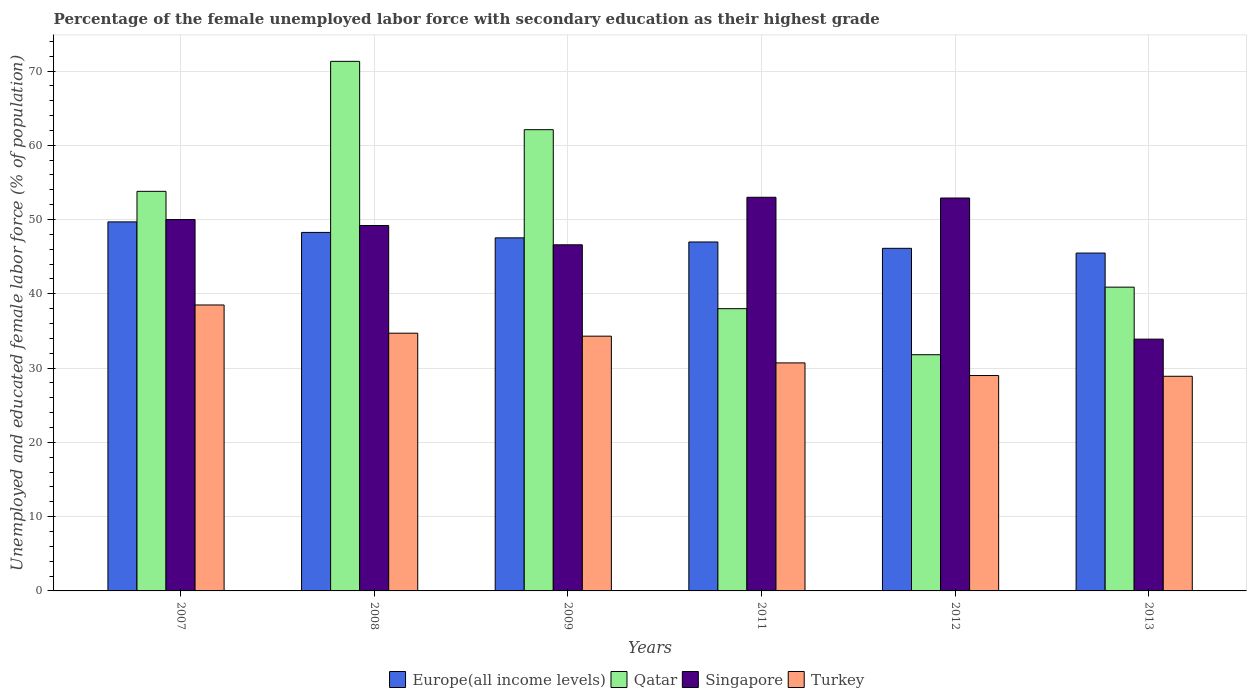How many different coloured bars are there?
Your answer should be very brief. 4. How many bars are there on the 4th tick from the left?
Give a very brief answer. 4. How many bars are there on the 2nd tick from the right?
Offer a terse response. 4. What is the label of the 4th group of bars from the left?
Offer a very short reply. 2011. What is the percentage of the unemployed female labor force with secondary education in Singapore in 2012?
Provide a short and direct response. 52.9. Across all years, what is the minimum percentage of the unemployed female labor force with secondary education in Europe(all income levels)?
Offer a very short reply. 45.49. In which year was the percentage of the unemployed female labor force with secondary education in Singapore maximum?
Offer a very short reply. 2011. What is the total percentage of the unemployed female labor force with secondary education in Qatar in the graph?
Provide a succinct answer. 297.9. What is the difference between the percentage of the unemployed female labor force with secondary education in Turkey in 2008 and that in 2011?
Ensure brevity in your answer.  4. What is the difference between the percentage of the unemployed female labor force with secondary education in Turkey in 2007 and the percentage of the unemployed female labor force with secondary education in Qatar in 2012?
Make the answer very short. 6.7. What is the average percentage of the unemployed female labor force with secondary education in Qatar per year?
Offer a terse response. 49.65. In the year 2011, what is the difference between the percentage of the unemployed female labor force with secondary education in Turkey and percentage of the unemployed female labor force with secondary education in Qatar?
Keep it short and to the point. -7.3. What is the ratio of the percentage of the unemployed female labor force with secondary education in Turkey in 2008 to that in 2012?
Your response must be concise. 1.2. Is the difference between the percentage of the unemployed female labor force with secondary education in Turkey in 2007 and 2012 greater than the difference between the percentage of the unemployed female labor force with secondary education in Qatar in 2007 and 2012?
Provide a succinct answer. No. What is the difference between the highest and the second highest percentage of the unemployed female labor force with secondary education in Singapore?
Keep it short and to the point. 0.1. What is the difference between the highest and the lowest percentage of the unemployed female labor force with secondary education in Turkey?
Provide a short and direct response. 9.6. Is the sum of the percentage of the unemployed female labor force with secondary education in Qatar in 2007 and 2013 greater than the maximum percentage of the unemployed female labor force with secondary education in Singapore across all years?
Provide a succinct answer. Yes. What does the 1st bar from the left in 2009 represents?
Ensure brevity in your answer.  Europe(all income levels). What does the 3rd bar from the right in 2009 represents?
Provide a short and direct response. Qatar. Is it the case that in every year, the sum of the percentage of the unemployed female labor force with secondary education in Europe(all income levels) and percentage of the unemployed female labor force with secondary education in Turkey is greater than the percentage of the unemployed female labor force with secondary education in Singapore?
Provide a short and direct response. Yes. How many bars are there?
Your answer should be compact. 24. Are all the bars in the graph horizontal?
Offer a very short reply. No. How many years are there in the graph?
Keep it short and to the point. 6. Does the graph contain any zero values?
Offer a very short reply. No. Does the graph contain grids?
Give a very brief answer. Yes. What is the title of the graph?
Offer a very short reply. Percentage of the female unemployed labor force with secondary education as their highest grade. What is the label or title of the Y-axis?
Keep it short and to the point. Unemployed and educated female labor force (% of population). What is the Unemployed and educated female labor force (% of population) in Europe(all income levels) in 2007?
Your answer should be very brief. 49.69. What is the Unemployed and educated female labor force (% of population) of Qatar in 2007?
Offer a terse response. 53.8. What is the Unemployed and educated female labor force (% of population) of Turkey in 2007?
Your answer should be very brief. 38.5. What is the Unemployed and educated female labor force (% of population) of Europe(all income levels) in 2008?
Provide a short and direct response. 48.27. What is the Unemployed and educated female labor force (% of population) of Qatar in 2008?
Provide a succinct answer. 71.3. What is the Unemployed and educated female labor force (% of population) of Singapore in 2008?
Make the answer very short. 49.2. What is the Unemployed and educated female labor force (% of population) in Turkey in 2008?
Provide a short and direct response. 34.7. What is the Unemployed and educated female labor force (% of population) in Europe(all income levels) in 2009?
Provide a succinct answer. 47.54. What is the Unemployed and educated female labor force (% of population) in Qatar in 2009?
Your answer should be compact. 62.1. What is the Unemployed and educated female labor force (% of population) in Singapore in 2009?
Make the answer very short. 46.6. What is the Unemployed and educated female labor force (% of population) of Turkey in 2009?
Provide a short and direct response. 34.3. What is the Unemployed and educated female labor force (% of population) of Europe(all income levels) in 2011?
Your response must be concise. 46.98. What is the Unemployed and educated female labor force (% of population) in Qatar in 2011?
Give a very brief answer. 38. What is the Unemployed and educated female labor force (% of population) in Turkey in 2011?
Your response must be concise. 30.7. What is the Unemployed and educated female labor force (% of population) of Europe(all income levels) in 2012?
Make the answer very short. 46.13. What is the Unemployed and educated female labor force (% of population) in Qatar in 2012?
Make the answer very short. 31.8. What is the Unemployed and educated female labor force (% of population) in Singapore in 2012?
Keep it short and to the point. 52.9. What is the Unemployed and educated female labor force (% of population) in Europe(all income levels) in 2013?
Give a very brief answer. 45.49. What is the Unemployed and educated female labor force (% of population) of Qatar in 2013?
Make the answer very short. 40.9. What is the Unemployed and educated female labor force (% of population) of Singapore in 2013?
Make the answer very short. 33.9. What is the Unemployed and educated female labor force (% of population) in Turkey in 2013?
Your response must be concise. 28.9. Across all years, what is the maximum Unemployed and educated female labor force (% of population) of Europe(all income levels)?
Your response must be concise. 49.69. Across all years, what is the maximum Unemployed and educated female labor force (% of population) in Qatar?
Make the answer very short. 71.3. Across all years, what is the maximum Unemployed and educated female labor force (% of population) of Singapore?
Offer a very short reply. 53. Across all years, what is the maximum Unemployed and educated female labor force (% of population) in Turkey?
Provide a succinct answer. 38.5. Across all years, what is the minimum Unemployed and educated female labor force (% of population) in Europe(all income levels)?
Give a very brief answer. 45.49. Across all years, what is the minimum Unemployed and educated female labor force (% of population) of Qatar?
Provide a succinct answer. 31.8. Across all years, what is the minimum Unemployed and educated female labor force (% of population) in Singapore?
Keep it short and to the point. 33.9. Across all years, what is the minimum Unemployed and educated female labor force (% of population) of Turkey?
Offer a very short reply. 28.9. What is the total Unemployed and educated female labor force (% of population) of Europe(all income levels) in the graph?
Offer a terse response. 284.09. What is the total Unemployed and educated female labor force (% of population) of Qatar in the graph?
Offer a terse response. 297.9. What is the total Unemployed and educated female labor force (% of population) of Singapore in the graph?
Give a very brief answer. 285.6. What is the total Unemployed and educated female labor force (% of population) in Turkey in the graph?
Your response must be concise. 196.1. What is the difference between the Unemployed and educated female labor force (% of population) in Europe(all income levels) in 2007 and that in 2008?
Ensure brevity in your answer.  1.42. What is the difference between the Unemployed and educated female labor force (% of population) of Qatar in 2007 and that in 2008?
Your response must be concise. -17.5. What is the difference between the Unemployed and educated female labor force (% of population) of Singapore in 2007 and that in 2008?
Give a very brief answer. 0.8. What is the difference between the Unemployed and educated female labor force (% of population) of Europe(all income levels) in 2007 and that in 2009?
Offer a terse response. 2.15. What is the difference between the Unemployed and educated female labor force (% of population) in Europe(all income levels) in 2007 and that in 2011?
Provide a succinct answer. 2.71. What is the difference between the Unemployed and educated female labor force (% of population) of Singapore in 2007 and that in 2011?
Keep it short and to the point. -3. What is the difference between the Unemployed and educated female labor force (% of population) in Turkey in 2007 and that in 2011?
Provide a short and direct response. 7.8. What is the difference between the Unemployed and educated female labor force (% of population) of Europe(all income levels) in 2007 and that in 2012?
Your response must be concise. 3.56. What is the difference between the Unemployed and educated female labor force (% of population) in Qatar in 2007 and that in 2012?
Provide a succinct answer. 22. What is the difference between the Unemployed and educated female labor force (% of population) in Singapore in 2007 and that in 2012?
Your answer should be very brief. -2.9. What is the difference between the Unemployed and educated female labor force (% of population) in Europe(all income levels) in 2007 and that in 2013?
Offer a very short reply. 4.2. What is the difference between the Unemployed and educated female labor force (% of population) of Turkey in 2007 and that in 2013?
Offer a terse response. 9.6. What is the difference between the Unemployed and educated female labor force (% of population) in Europe(all income levels) in 2008 and that in 2009?
Your answer should be very brief. 0.73. What is the difference between the Unemployed and educated female labor force (% of population) in Qatar in 2008 and that in 2009?
Give a very brief answer. 9.2. What is the difference between the Unemployed and educated female labor force (% of population) in Singapore in 2008 and that in 2009?
Give a very brief answer. 2.6. What is the difference between the Unemployed and educated female labor force (% of population) of Turkey in 2008 and that in 2009?
Your answer should be very brief. 0.4. What is the difference between the Unemployed and educated female labor force (% of population) in Europe(all income levels) in 2008 and that in 2011?
Ensure brevity in your answer.  1.29. What is the difference between the Unemployed and educated female labor force (% of population) of Qatar in 2008 and that in 2011?
Ensure brevity in your answer.  33.3. What is the difference between the Unemployed and educated female labor force (% of population) of Europe(all income levels) in 2008 and that in 2012?
Provide a succinct answer. 2.14. What is the difference between the Unemployed and educated female labor force (% of population) of Qatar in 2008 and that in 2012?
Provide a short and direct response. 39.5. What is the difference between the Unemployed and educated female labor force (% of population) of Singapore in 2008 and that in 2012?
Provide a short and direct response. -3.7. What is the difference between the Unemployed and educated female labor force (% of population) in Europe(all income levels) in 2008 and that in 2013?
Provide a short and direct response. 2.78. What is the difference between the Unemployed and educated female labor force (% of population) in Qatar in 2008 and that in 2013?
Keep it short and to the point. 30.4. What is the difference between the Unemployed and educated female labor force (% of population) of Europe(all income levels) in 2009 and that in 2011?
Your answer should be compact. 0.56. What is the difference between the Unemployed and educated female labor force (% of population) of Qatar in 2009 and that in 2011?
Your answer should be compact. 24.1. What is the difference between the Unemployed and educated female labor force (% of population) in Singapore in 2009 and that in 2011?
Your answer should be compact. -6.4. What is the difference between the Unemployed and educated female labor force (% of population) of Europe(all income levels) in 2009 and that in 2012?
Provide a short and direct response. 1.41. What is the difference between the Unemployed and educated female labor force (% of population) in Qatar in 2009 and that in 2012?
Your answer should be compact. 30.3. What is the difference between the Unemployed and educated female labor force (% of population) of Europe(all income levels) in 2009 and that in 2013?
Provide a short and direct response. 2.05. What is the difference between the Unemployed and educated female labor force (% of population) in Qatar in 2009 and that in 2013?
Offer a very short reply. 21.2. What is the difference between the Unemployed and educated female labor force (% of population) in Singapore in 2009 and that in 2013?
Provide a short and direct response. 12.7. What is the difference between the Unemployed and educated female labor force (% of population) of Europe(all income levels) in 2011 and that in 2012?
Offer a terse response. 0.85. What is the difference between the Unemployed and educated female labor force (% of population) in Qatar in 2011 and that in 2012?
Give a very brief answer. 6.2. What is the difference between the Unemployed and educated female labor force (% of population) of Singapore in 2011 and that in 2012?
Provide a succinct answer. 0.1. What is the difference between the Unemployed and educated female labor force (% of population) of Europe(all income levels) in 2011 and that in 2013?
Ensure brevity in your answer.  1.49. What is the difference between the Unemployed and educated female labor force (% of population) in Turkey in 2011 and that in 2013?
Give a very brief answer. 1.8. What is the difference between the Unemployed and educated female labor force (% of population) of Europe(all income levels) in 2012 and that in 2013?
Give a very brief answer. 0.64. What is the difference between the Unemployed and educated female labor force (% of population) of Qatar in 2012 and that in 2013?
Keep it short and to the point. -9.1. What is the difference between the Unemployed and educated female labor force (% of population) of Singapore in 2012 and that in 2013?
Offer a very short reply. 19. What is the difference between the Unemployed and educated female labor force (% of population) of Europe(all income levels) in 2007 and the Unemployed and educated female labor force (% of population) of Qatar in 2008?
Keep it short and to the point. -21.61. What is the difference between the Unemployed and educated female labor force (% of population) of Europe(all income levels) in 2007 and the Unemployed and educated female labor force (% of population) of Singapore in 2008?
Offer a very short reply. 0.49. What is the difference between the Unemployed and educated female labor force (% of population) in Europe(all income levels) in 2007 and the Unemployed and educated female labor force (% of population) in Turkey in 2008?
Offer a very short reply. 14.99. What is the difference between the Unemployed and educated female labor force (% of population) of Singapore in 2007 and the Unemployed and educated female labor force (% of population) of Turkey in 2008?
Your response must be concise. 15.3. What is the difference between the Unemployed and educated female labor force (% of population) of Europe(all income levels) in 2007 and the Unemployed and educated female labor force (% of population) of Qatar in 2009?
Your response must be concise. -12.41. What is the difference between the Unemployed and educated female labor force (% of population) in Europe(all income levels) in 2007 and the Unemployed and educated female labor force (% of population) in Singapore in 2009?
Your answer should be compact. 3.09. What is the difference between the Unemployed and educated female labor force (% of population) in Europe(all income levels) in 2007 and the Unemployed and educated female labor force (% of population) in Turkey in 2009?
Give a very brief answer. 15.39. What is the difference between the Unemployed and educated female labor force (% of population) of Qatar in 2007 and the Unemployed and educated female labor force (% of population) of Singapore in 2009?
Provide a short and direct response. 7.2. What is the difference between the Unemployed and educated female labor force (% of population) of Singapore in 2007 and the Unemployed and educated female labor force (% of population) of Turkey in 2009?
Ensure brevity in your answer.  15.7. What is the difference between the Unemployed and educated female labor force (% of population) of Europe(all income levels) in 2007 and the Unemployed and educated female labor force (% of population) of Qatar in 2011?
Give a very brief answer. 11.69. What is the difference between the Unemployed and educated female labor force (% of population) in Europe(all income levels) in 2007 and the Unemployed and educated female labor force (% of population) in Singapore in 2011?
Your answer should be very brief. -3.31. What is the difference between the Unemployed and educated female labor force (% of population) of Europe(all income levels) in 2007 and the Unemployed and educated female labor force (% of population) of Turkey in 2011?
Provide a short and direct response. 18.99. What is the difference between the Unemployed and educated female labor force (% of population) in Qatar in 2007 and the Unemployed and educated female labor force (% of population) in Singapore in 2011?
Make the answer very short. 0.8. What is the difference between the Unemployed and educated female labor force (% of population) of Qatar in 2007 and the Unemployed and educated female labor force (% of population) of Turkey in 2011?
Make the answer very short. 23.1. What is the difference between the Unemployed and educated female labor force (% of population) of Singapore in 2007 and the Unemployed and educated female labor force (% of population) of Turkey in 2011?
Provide a succinct answer. 19.3. What is the difference between the Unemployed and educated female labor force (% of population) of Europe(all income levels) in 2007 and the Unemployed and educated female labor force (% of population) of Qatar in 2012?
Your response must be concise. 17.89. What is the difference between the Unemployed and educated female labor force (% of population) in Europe(all income levels) in 2007 and the Unemployed and educated female labor force (% of population) in Singapore in 2012?
Provide a succinct answer. -3.21. What is the difference between the Unemployed and educated female labor force (% of population) in Europe(all income levels) in 2007 and the Unemployed and educated female labor force (% of population) in Turkey in 2012?
Your answer should be compact. 20.69. What is the difference between the Unemployed and educated female labor force (% of population) of Qatar in 2007 and the Unemployed and educated female labor force (% of population) of Turkey in 2012?
Make the answer very short. 24.8. What is the difference between the Unemployed and educated female labor force (% of population) of Singapore in 2007 and the Unemployed and educated female labor force (% of population) of Turkey in 2012?
Offer a terse response. 21. What is the difference between the Unemployed and educated female labor force (% of population) of Europe(all income levels) in 2007 and the Unemployed and educated female labor force (% of population) of Qatar in 2013?
Keep it short and to the point. 8.79. What is the difference between the Unemployed and educated female labor force (% of population) in Europe(all income levels) in 2007 and the Unemployed and educated female labor force (% of population) in Singapore in 2013?
Give a very brief answer. 15.79. What is the difference between the Unemployed and educated female labor force (% of population) in Europe(all income levels) in 2007 and the Unemployed and educated female labor force (% of population) in Turkey in 2013?
Your response must be concise. 20.79. What is the difference between the Unemployed and educated female labor force (% of population) in Qatar in 2007 and the Unemployed and educated female labor force (% of population) in Singapore in 2013?
Your answer should be compact. 19.9. What is the difference between the Unemployed and educated female labor force (% of population) of Qatar in 2007 and the Unemployed and educated female labor force (% of population) of Turkey in 2013?
Offer a very short reply. 24.9. What is the difference between the Unemployed and educated female labor force (% of population) of Singapore in 2007 and the Unemployed and educated female labor force (% of population) of Turkey in 2013?
Provide a succinct answer. 21.1. What is the difference between the Unemployed and educated female labor force (% of population) of Europe(all income levels) in 2008 and the Unemployed and educated female labor force (% of population) of Qatar in 2009?
Offer a terse response. -13.83. What is the difference between the Unemployed and educated female labor force (% of population) of Europe(all income levels) in 2008 and the Unemployed and educated female labor force (% of population) of Singapore in 2009?
Offer a very short reply. 1.67. What is the difference between the Unemployed and educated female labor force (% of population) of Europe(all income levels) in 2008 and the Unemployed and educated female labor force (% of population) of Turkey in 2009?
Provide a succinct answer. 13.97. What is the difference between the Unemployed and educated female labor force (% of population) in Qatar in 2008 and the Unemployed and educated female labor force (% of population) in Singapore in 2009?
Provide a short and direct response. 24.7. What is the difference between the Unemployed and educated female labor force (% of population) in Europe(all income levels) in 2008 and the Unemployed and educated female labor force (% of population) in Qatar in 2011?
Your answer should be compact. 10.27. What is the difference between the Unemployed and educated female labor force (% of population) in Europe(all income levels) in 2008 and the Unemployed and educated female labor force (% of population) in Singapore in 2011?
Offer a very short reply. -4.73. What is the difference between the Unemployed and educated female labor force (% of population) of Europe(all income levels) in 2008 and the Unemployed and educated female labor force (% of population) of Turkey in 2011?
Keep it short and to the point. 17.57. What is the difference between the Unemployed and educated female labor force (% of population) in Qatar in 2008 and the Unemployed and educated female labor force (% of population) in Turkey in 2011?
Give a very brief answer. 40.6. What is the difference between the Unemployed and educated female labor force (% of population) of Europe(all income levels) in 2008 and the Unemployed and educated female labor force (% of population) of Qatar in 2012?
Your answer should be compact. 16.47. What is the difference between the Unemployed and educated female labor force (% of population) in Europe(all income levels) in 2008 and the Unemployed and educated female labor force (% of population) in Singapore in 2012?
Keep it short and to the point. -4.63. What is the difference between the Unemployed and educated female labor force (% of population) of Europe(all income levels) in 2008 and the Unemployed and educated female labor force (% of population) of Turkey in 2012?
Make the answer very short. 19.27. What is the difference between the Unemployed and educated female labor force (% of population) in Qatar in 2008 and the Unemployed and educated female labor force (% of population) in Singapore in 2012?
Your response must be concise. 18.4. What is the difference between the Unemployed and educated female labor force (% of population) in Qatar in 2008 and the Unemployed and educated female labor force (% of population) in Turkey in 2012?
Give a very brief answer. 42.3. What is the difference between the Unemployed and educated female labor force (% of population) in Singapore in 2008 and the Unemployed and educated female labor force (% of population) in Turkey in 2012?
Offer a very short reply. 20.2. What is the difference between the Unemployed and educated female labor force (% of population) in Europe(all income levels) in 2008 and the Unemployed and educated female labor force (% of population) in Qatar in 2013?
Keep it short and to the point. 7.37. What is the difference between the Unemployed and educated female labor force (% of population) of Europe(all income levels) in 2008 and the Unemployed and educated female labor force (% of population) of Singapore in 2013?
Keep it short and to the point. 14.37. What is the difference between the Unemployed and educated female labor force (% of population) in Europe(all income levels) in 2008 and the Unemployed and educated female labor force (% of population) in Turkey in 2013?
Give a very brief answer. 19.37. What is the difference between the Unemployed and educated female labor force (% of population) of Qatar in 2008 and the Unemployed and educated female labor force (% of population) of Singapore in 2013?
Your answer should be compact. 37.4. What is the difference between the Unemployed and educated female labor force (% of population) of Qatar in 2008 and the Unemployed and educated female labor force (% of population) of Turkey in 2013?
Ensure brevity in your answer.  42.4. What is the difference between the Unemployed and educated female labor force (% of population) of Singapore in 2008 and the Unemployed and educated female labor force (% of population) of Turkey in 2013?
Make the answer very short. 20.3. What is the difference between the Unemployed and educated female labor force (% of population) in Europe(all income levels) in 2009 and the Unemployed and educated female labor force (% of population) in Qatar in 2011?
Your response must be concise. 9.54. What is the difference between the Unemployed and educated female labor force (% of population) of Europe(all income levels) in 2009 and the Unemployed and educated female labor force (% of population) of Singapore in 2011?
Your answer should be very brief. -5.46. What is the difference between the Unemployed and educated female labor force (% of population) of Europe(all income levels) in 2009 and the Unemployed and educated female labor force (% of population) of Turkey in 2011?
Your response must be concise. 16.84. What is the difference between the Unemployed and educated female labor force (% of population) of Qatar in 2009 and the Unemployed and educated female labor force (% of population) of Singapore in 2011?
Your answer should be very brief. 9.1. What is the difference between the Unemployed and educated female labor force (% of population) of Qatar in 2009 and the Unemployed and educated female labor force (% of population) of Turkey in 2011?
Give a very brief answer. 31.4. What is the difference between the Unemployed and educated female labor force (% of population) in Singapore in 2009 and the Unemployed and educated female labor force (% of population) in Turkey in 2011?
Your answer should be very brief. 15.9. What is the difference between the Unemployed and educated female labor force (% of population) of Europe(all income levels) in 2009 and the Unemployed and educated female labor force (% of population) of Qatar in 2012?
Ensure brevity in your answer.  15.74. What is the difference between the Unemployed and educated female labor force (% of population) in Europe(all income levels) in 2009 and the Unemployed and educated female labor force (% of population) in Singapore in 2012?
Your answer should be very brief. -5.36. What is the difference between the Unemployed and educated female labor force (% of population) of Europe(all income levels) in 2009 and the Unemployed and educated female labor force (% of population) of Turkey in 2012?
Your answer should be very brief. 18.54. What is the difference between the Unemployed and educated female labor force (% of population) in Qatar in 2009 and the Unemployed and educated female labor force (% of population) in Singapore in 2012?
Ensure brevity in your answer.  9.2. What is the difference between the Unemployed and educated female labor force (% of population) of Qatar in 2009 and the Unemployed and educated female labor force (% of population) of Turkey in 2012?
Make the answer very short. 33.1. What is the difference between the Unemployed and educated female labor force (% of population) of Singapore in 2009 and the Unemployed and educated female labor force (% of population) of Turkey in 2012?
Your answer should be compact. 17.6. What is the difference between the Unemployed and educated female labor force (% of population) of Europe(all income levels) in 2009 and the Unemployed and educated female labor force (% of population) of Qatar in 2013?
Give a very brief answer. 6.64. What is the difference between the Unemployed and educated female labor force (% of population) of Europe(all income levels) in 2009 and the Unemployed and educated female labor force (% of population) of Singapore in 2013?
Your answer should be very brief. 13.64. What is the difference between the Unemployed and educated female labor force (% of population) of Europe(all income levels) in 2009 and the Unemployed and educated female labor force (% of population) of Turkey in 2013?
Ensure brevity in your answer.  18.64. What is the difference between the Unemployed and educated female labor force (% of population) of Qatar in 2009 and the Unemployed and educated female labor force (% of population) of Singapore in 2013?
Your response must be concise. 28.2. What is the difference between the Unemployed and educated female labor force (% of population) in Qatar in 2009 and the Unemployed and educated female labor force (% of population) in Turkey in 2013?
Give a very brief answer. 33.2. What is the difference between the Unemployed and educated female labor force (% of population) in Europe(all income levels) in 2011 and the Unemployed and educated female labor force (% of population) in Qatar in 2012?
Your response must be concise. 15.18. What is the difference between the Unemployed and educated female labor force (% of population) of Europe(all income levels) in 2011 and the Unemployed and educated female labor force (% of population) of Singapore in 2012?
Keep it short and to the point. -5.92. What is the difference between the Unemployed and educated female labor force (% of population) in Europe(all income levels) in 2011 and the Unemployed and educated female labor force (% of population) in Turkey in 2012?
Keep it short and to the point. 17.98. What is the difference between the Unemployed and educated female labor force (% of population) of Qatar in 2011 and the Unemployed and educated female labor force (% of population) of Singapore in 2012?
Your answer should be compact. -14.9. What is the difference between the Unemployed and educated female labor force (% of population) of Qatar in 2011 and the Unemployed and educated female labor force (% of population) of Turkey in 2012?
Your answer should be very brief. 9. What is the difference between the Unemployed and educated female labor force (% of population) in Singapore in 2011 and the Unemployed and educated female labor force (% of population) in Turkey in 2012?
Make the answer very short. 24. What is the difference between the Unemployed and educated female labor force (% of population) of Europe(all income levels) in 2011 and the Unemployed and educated female labor force (% of population) of Qatar in 2013?
Offer a very short reply. 6.08. What is the difference between the Unemployed and educated female labor force (% of population) of Europe(all income levels) in 2011 and the Unemployed and educated female labor force (% of population) of Singapore in 2013?
Offer a very short reply. 13.08. What is the difference between the Unemployed and educated female labor force (% of population) in Europe(all income levels) in 2011 and the Unemployed and educated female labor force (% of population) in Turkey in 2013?
Your answer should be compact. 18.08. What is the difference between the Unemployed and educated female labor force (% of population) in Qatar in 2011 and the Unemployed and educated female labor force (% of population) in Turkey in 2013?
Your response must be concise. 9.1. What is the difference between the Unemployed and educated female labor force (% of population) in Singapore in 2011 and the Unemployed and educated female labor force (% of population) in Turkey in 2013?
Give a very brief answer. 24.1. What is the difference between the Unemployed and educated female labor force (% of population) in Europe(all income levels) in 2012 and the Unemployed and educated female labor force (% of population) in Qatar in 2013?
Your answer should be compact. 5.23. What is the difference between the Unemployed and educated female labor force (% of population) in Europe(all income levels) in 2012 and the Unemployed and educated female labor force (% of population) in Singapore in 2013?
Make the answer very short. 12.23. What is the difference between the Unemployed and educated female labor force (% of population) in Europe(all income levels) in 2012 and the Unemployed and educated female labor force (% of population) in Turkey in 2013?
Your answer should be very brief. 17.23. What is the average Unemployed and educated female labor force (% of population) in Europe(all income levels) per year?
Provide a short and direct response. 47.35. What is the average Unemployed and educated female labor force (% of population) in Qatar per year?
Offer a very short reply. 49.65. What is the average Unemployed and educated female labor force (% of population) of Singapore per year?
Offer a terse response. 47.6. What is the average Unemployed and educated female labor force (% of population) of Turkey per year?
Keep it short and to the point. 32.68. In the year 2007, what is the difference between the Unemployed and educated female labor force (% of population) of Europe(all income levels) and Unemployed and educated female labor force (% of population) of Qatar?
Your answer should be compact. -4.11. In the year 2007, what is the difference between the Unemployed and educated female labor force (% of population) in Europe(all income levels) and Unemployed and educated female labor force (% of population) in Singapore?
Make the answer very short. -0.31. In the year 2007, what is the difference between the Unemployed and educated female labor force (% of population) in Europe(all income levels) and Unemployed and educated female labor force (% of population) in Turkey?
Provide a succinct answer. 11.19. In the year 2007, what is the difference between the Unemployed and educated female labor force (% of population) in Qatar and Unemployed and educated female labor force (% of population) in Turkey?
Provide a short and direct response. 15.3. In the year 2007, what is the difference between the Unemployed and educated female labor force (% of population) of Singapore and Unemployed and educated female labor force (% of population) of Turkey?
Your answer should be compact. 11.5. In the year 2008, what is the difference between the Unemployed and educated female labor force (% of population) in Europe(all income levels) and Unemployed and educated female labor force (% of population) in Qatar?
Your answer should be very brief. -23.03. In the year 2008, what is the difference between the Unemployed and educated female labor force (% of population) of Europe(all income levels) and Unemployed and educated female labor force (% of population) of Singapore?
Offer a terse response. -0.93. In the year 2008, what is the difference between the Unemployed and educated female labor force (% of population) of Europe(all income levels) and Unemployed and educated female labor force (% of population) of Turkey?
Make the answer very short. 13.57. In the year 2008, what is the difference between the Unemployed and educated female labor force (% of population) in Qatar and Unemployed and educated female labor force (% of population) in Singapore?
Provide a short and direct response. 22.1. In the year 2008, what is the difference between the Unemployed and educated female labor force (% of population) of Qatar and Unemployed and educated female labor force (% of population) of Turkey?
Give a very brief answer. 36.6. In the year 2009, what is the difference between the Unemployed and educated female labor force (% of population) in Europe(all income levels) and Unemployed and educated female labor force (% of population) in Qatar?
Your answer should be very brief. -14.56. In the year 2009, what is the difference between the Unemployed and educated female labor force (% of population) of Europe(all income levels) and Unemployed and educated female labor force (% of population) of Singapore?
Offer a terse response. 0.94. In the year 2009, what is the difference between the Unemployed and educated female labor force (% of population) in Europe(all income levels) and Unemployed and educated female labor force (% of population) in Turkey?
Keep it short and to the point. 13.24. In the year 2009, what is the difference between the Unemployed and educated female labor force (% of population) of Qatar and Unemployed and educated female labor force (% of population) of Singapore?
Provide a succinct answer. 15.5. In the year 2009, what is the difference between the Unemployed and educated female labor force (% of population) in Qatar and Unemployed and educated female labor force (% of population) in Turkey?
Your response must be concise. 27.8. In the year 2009, what is the difference between the Unemployed and educated female labor force (% of population) of Singapore and Unemployed and educated female labor force (% of population) of Turkey?
Provide a succinct answer. 12.3. In the year 2011, what is the difference between the Unemployed and educated female labor force (% of population) in Europe(all income levels) and Unemployed and educated female labor force (% of population) in Qatar?
Your answer should be compact. 8.98. In the year 2011, what is the difference between the Unemployed and educated female labor force (% of population) in Europe(all income levels) and Unemployed and educated female labor force (% of population) in Singapore?
Provide a succinct answer. -6.02. In the year 2011, what is the difference between the Unemployed and educated female labor force (% of population) of Europe(all income levels) and Unemployed and educated female labor force (% of population) of Turkey?
Keep it short and to the point. 16.28. In the year 2011, what is the difference between the Unemployed and educated female labor force (% of population) of Qatar and Unemployed and educated female labor force (% of population) of Turkey?
Offer a terse response. 7.3. In the year 2011, what is the difference between the Unemployed and educated female labor force (% of population) in Singapore and Unemployed and educated female labor force (% of population) in Turkey?
Provide a short and direct response. 22.3. In the year 2012, what is the difference between the Unemployed and educated female labor force (% of population) in Europe(all income levels) and Unemployed and educated female labor force (% of population) in Qatar?
Give a very brief answer. 14.33. In the year 2012, what is the difference between the Unemployed and educated female labor force (% of population) in Europe(all income levels) and Unemployed and educated female labor force (% of population) in Singapore?
Your response must be concise. -6.77. In the year 2012, what is the difference between the Unemployed and educated female labor force (% of population) in Europe(all income levels) and Unemployed and educated female labor force (% of population) in Turkey?
Your answer should be compact. 17.13. In the year 2012, what is the difference between the Unemployed and educated female labor force (% of population) in Qatar and Unemployed and educated female labor force (% of population) in Singapore?
Make the answer very short. -21.1. In the year 2012, what is the difference between the Unemployed and educated female labor force (% of population) in Qatar and Unemployed and educated female labor force (% of population) in Turkey?
Give a very brief answer. 2.8. In the year 2012, what is the difference between the Unemployed and educated female labor force (% of population) of Singapore and Unemployed and educated female labor force (% of population) of Turkey?
Make the answer very short. 23.9. In the year 2013, what is the difference between the Unemployed and educated female labor force (% of population) in Europe(all income levels) and Unemployed and educated female labor force (% of population) in Qatar?
Give a very brief answer. 4.59. In the year 2013, what is the difference between the Unemployed and educated female labor force (% of population) of Europe(all income levels) and Unemployed and educated female labor force (% of population) of Singapore?
Offer a terse response. 11.59. In the year 2013, what is the difference between the Unemployed and educated female labor force (% of population) of Europe(all income levels) and Unemployed and educated female labor force (% of population) of Turkey?
Offer a very short reply. 16.59. In the year 2013, what is the difference between the Unemployed and educated female labor force (% of population) of Qatar and Unemployed and educated female labor force (% of population) of Singapore?
Provide a succinct answer. 7. In the year 2013, what is the difference between the Unemployed and educated female labor force (% of population) of Qatar and Unemployed and educated female labor force (% of population) of Turkey?
Make the answer very short. 12. In the year 2013, what is the difference between the Unemployed and educated female labor force (% of population) of Singapore and Unemployed and educated female labor force (% of population) of Turkey?
Give a very brief answer. 5. What is the ratio of the Unemployed and educated female labor force (% of population) of Europe(all income levels) in 2007 to that in 2008?
Provide a succinct answer. 1.03. What is the ratio of the Unemployed and educated female labor force (% of population) in Qatar in 2007 to that in 2008?
Provide a short and direct response. 0.75. What is the ratio of the Unemployed and educated female labor force (% of population) in Singapore in 2007 to that in 2008?
Keep it short and to the point. 1.02. What is the ratio of the Unemployed and educated female labor force (% of population) in Turkey in 2007 to that in 2008?
Keep it short and to the point. 1.11. What is the ratio of the Unemployed and educated female labor force (% of population) in Europe(all income levels) in 2007 to that in 2009?
Your answer should be very brief. 1.05. What is the ratio of the Unemployed and educated female labor force (% of population) in Qatar in 2007 to that in 2009?
Your response must be concise. 0.87. What is the ratio of the Unemployed and educated female labor force (% of population) in Singapore in 2007 to that in 2009?
Your answer should be very brief. 1.07. What is the ratio of the Unemployed and educated female labor force (% of population) of Turkey in 2007 to that in 2009?
Give a very brief answer. 1.12. What is the ratio of the Unemployed and educated female labor force (% of population) of Europe(all income levels) in 2007 to that in 2011?
Ensure brevity in your answer.  1.06. What is the ratio of the Unemployed and educated female labor force (% of population) of Qatar in 2007 to that in 2011?
Offer a very short reply. 1.42. What is the ratio of the Unemployed and educated female labor force (% of population) in Singapore in 2007 to that in 2011?
Your answer should be very brief. 0.94. What is the ratio of the Unemployed and educated female labor force (% of population) of Turkey in 2007 to that in 2011?
Your response must be concise. 1.25. What is the ratio of the Unemployed and educated female labor force (% of population) of Europe(all income levels) in 2007 to that in 2012?
Keep it short and to the point. 1.08. What is the ratio of the Unemployed and educated female labor force (% of population) of Qatar in 2007 to that in 2012?
Provide a short and direct response. 1.69. What is the ratio of the Unemployed and educated female labor force (% of population) of Singapore in 2007 to that in 2012?
Your answer should be compact. 0.95. What is the ratio of the Unemployed and educated female labor force (% of population) of Turkey in 2007 to that in 2012?
Keep it short and to the point. 1.33. What is the ratio of the Unemployed and educated female labor force (% of population) in Europe(all income levels) in 2007 to that in 2013?
Make the answer very short. 1.09. What is the ratio of the Unemployed and educated female labor force (% of population) of Qatar in 2007 to that in 2013?
Your answer should be very brief. 1.32. What is the ratio of the Unemployed and educated female labor force (% of population) of Singapore in 2007 to that in 2013?
Offer a very short reply. 1.47. What is the ratio of the Unemployed and educated female labor force (% of population) of Turkey in 2007 to that in 2013?
Give a very brief answer. 1.33. What is the ratio of the Unemployed and educated female labor force (% of population) of Europe(all income levels) in 2008 to that in 2009?
Your answer should be compact. 1.02. What is the ratio of the Unemployed and educated female labor force (% of population) of Qatar in 2008 to that in 2009?
Make the answer very short. 1.15. What is the ratio of the Unemployed and educated female labor force (% of population) of Singapore in 2008 to that in 2009?
Give a very brief answer. 1.06. What is the ratio of the Unemployed and educated female labor force (% of population) in Turkey in 2008 to that in 2009?
Provide a succinct answer. 1.01. What is the ratio of the Unemployed and educated female labor force (% of population) of Europe(all income levels) in 2008 to that in 2011?
Make the answer very short. 1.03. What is the ratio of the Unemployed and educated female labor force (% of population) in Qatar in 2008 to that in 2011?
Make the answer very short. 1.88. What is the ratio of the Unemployed and educated female labor force (% of population) in Singapore in 2008 to that in 2011?
Give a very brief answer. 0.93. What is the ratio of the Unemployed and educated female labor force (% of population) in Turkey in 2008 to that in 2011?
Provide a short and direct response. 1.13. What is the ratio of the Unemployed and educated female labor force (% of population) in Europe(all income levels) in 2008 to that in 2012?
Offer a terse response. 1.05. What is the ratio of the Unemployed and educated female labor force (% of population) of Qatar in 2008 to that in 2012?
Your answer should be compact. 2.24. What is the ratio of the Unemployed and educated female labor force (% of population) in Singapore in 2008 to that in 2012?
Ensure brevity in your answer.  0.93. What is the ratio of the Unemployed and educated female labor force (% of population) in Turkey in 2008 to that in 2012?
Your answer should be compact. 1.2. What is the ratio of the Unemployed and educated female labor force (% of population) in Europe(all income levels) in 2008 to that in 2013?
Your response must be concise. 1.06. What is the ratio of the Unemployed and educated female labor force (% of population) in Qatar in 2008 to that in 2013?
Keep it short and to the point. 1.74. What is the ratio of the Unemployed and educated female labor force (% of population) in Singapore in 2008 to that in 2013?
Your answer should be very brief. 1.45. What is the ratio of the Unemployed and educated female labor force (% of population) of Turkey in 2008 to that in 2013?
Give a very brief answer. 1.2. What is the ratio of the Unemployed and educated female labor force (% of population) of Europe(all income levels) in 2009 to that in 2011?
Provide a succinct answer. 1.01. What is the ratio of the Unemployed and educated female labor force (% of population) in Qatar in 2009 to that in 2011?
Your answer should be compact. 1.63. What is the ratio of the Unemployed and educated female labor force (% of population) of Singapore in 2009 to that in 2011?
Provide a short and direct response. 0.88. What is the ratio of the Unemployed and educated female labor force (% of population) in Turkey in 2009 to that in 2011?
Make the answer very short. 1.12. What is the ratio of the Unemployed and educated female labor force (% of population) of Europe(all income levels) in 2009 to that in 2012?
Make the answer very short. 1.03. What is the ratio of the Unemployed and educated female labor force (% of population) of Qatar in 2009 to that in 2012?
Give a very brief answer. 1.95. What is the ratio of the Unemployed and educated female labor force (% of population) in Singapore in 2009 to that in 2012?
Offer a terse response. 0.88. What is the ratio of the Unemployed and educated female labor force (% of population) in Turkey in 2009 to that in 2012?
Keep it short and to the point. 1.18. What is the ratio of the Unemployed and educated female labor force (% of population) in Europe(all income levels) in 2009 to that in 2013?
Make the answer very short. 1.04. What is the ratio of the Unemployed and educated female labor force (% of population) of Qatar in 2009 to that in 2013?
Give a very brief answer. 1.52. What is the ratio of the Unemployed and educated female labor force (% of population) of Singapore in 2009 to that in 2013?
Your answer should be compact. 1.37. What is the ratio of the Unemployed and educated female labor force (% of population) of Turkey in 2009 to that in 2013?
Offer a very short reply. 1.19. What is the ratio of the Unemployed and educated female labor force (% of population) of Europe(all income levels) in 2011 to that in 2012?
Keep it short and to the point. 1.02. What is the ratio of the Unemployed and educated female labor force (% of population) of Qatar in 2011 to that in 2012?
Offer a terse response. 1.2. What is the ratio of the Unemployed and educated female labor force (% of population) of Singapore in 2011 to that in 2012?
Your answer should be very brief. 1. What is the ratio of the Unemployed and educated female labor force (% of population) of Turkey in 2011 to that in 2012?
Ensure brevity in your answer.  1.06. What is the ratio of the Unemployed and educated female labor force (% of population) in Europe(all income levels) in 2011 to that in 2013?
Your answer should be very brief. 1.03. What is the ratio of the Unemployed and educated female labor force (% of population) of Qatar in 2011 to that in 2013?
Make the answer very short. 0.93. What is the ratio of the Unemployed and educated female labor force (% of population) in Singapore in 2011 to that in 2013?
Offer a terse response. 1.56. What is the ratio of the Unemployed and educated female labor force (% of population) of Turkey in 2011 to that in 2013?
Ensure brevity in your answer.  1.06. What is the ratio of the Unemployed and educated female labor force (% of population) in Europe(all income levels) in 2012 to that in 2013?
Offer a very short reply. 1.01. What is the ratio of the Unemployed and educated female labor force (% of population) of Qatar in 2012 to that in 2013?
Give a very brief answer. 0.78. What is the ratio of the Unemployed and educated female labor force (% of population) in Singapore in 2012 to that in 2013?
Offer a terse response. 1.56. What is the ratio of the Unemployed and educated female labor force (% of population) in Turkey in 2012 to that in 2013?
Provide a succinct answer. 1. What is the difference between the highest and the second highest Unemployed and educated female labor force (% of population) in Europe(all income levels)?
Keep it short and to the point. 1.42. What is the difference between the highest and the second highest Unemployed and educated female labor force (% of population) in Qatar?
Make the answer very short. 9.2. What is the difference between the highest and the second highest Unemployed and educated female labor force (% of population) in Singapore?
Your answer should be compact. 0.1. What is the difference between the highest and the lowest Unemployed and educated female labor force (% of population) in Europe(all income levels)?
Provide a short and direct response. 4.2. What is the difference between the highest and the lowest Unemployed and educated female labor force (% of population) of Qatar?
Offer a terse response. 39.5. What is the difference between the highest and the lowest Unemployed and educated female labor force (% of population) in Turkey?
Offer a terse response. 9.6. 